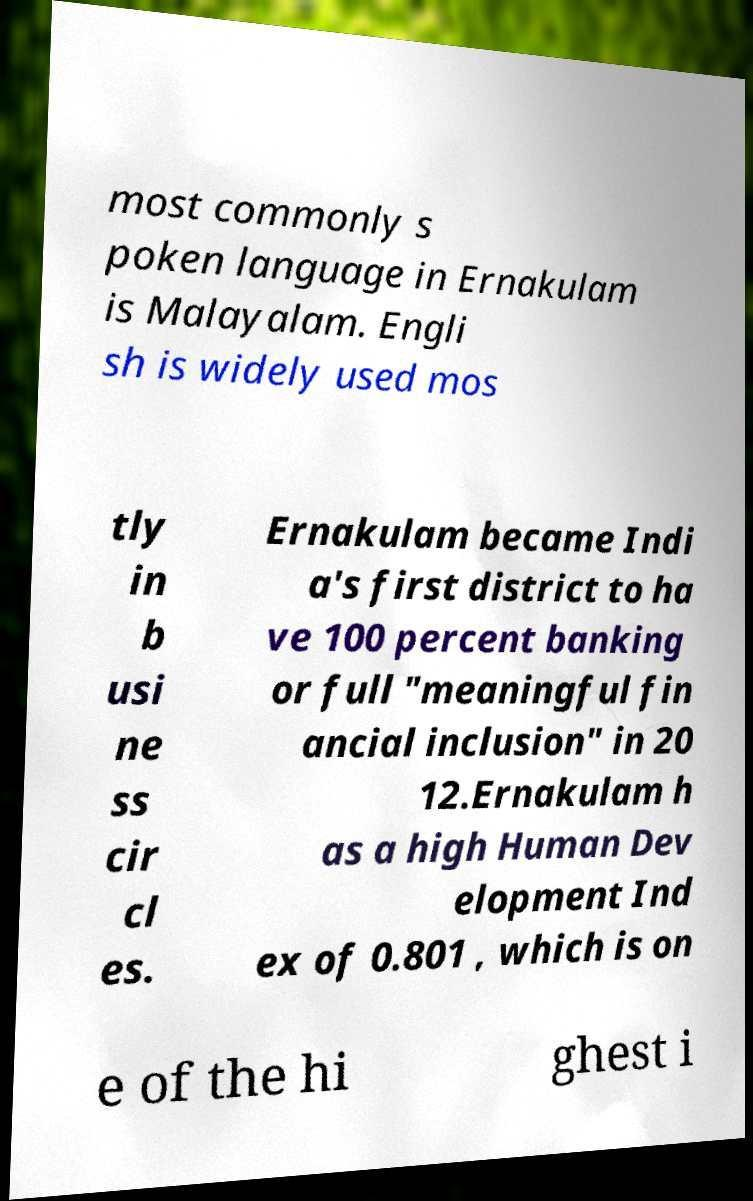What messages or text are displayed in this image? I need them in a readable, typed format. most commonly s poken language in Ernakulam is Malayalam. Engli sh is widely used mos tly in b usi ne ss cir cl es. Ernakulam became Indi a's first district to ha ve 100 percent banking or full "meaningful fin ancial inclusion" in 20 12.Ernakulam h as a high Human Dev elopment Ind ex of 0.801 , which is on e of the hi ghest i 